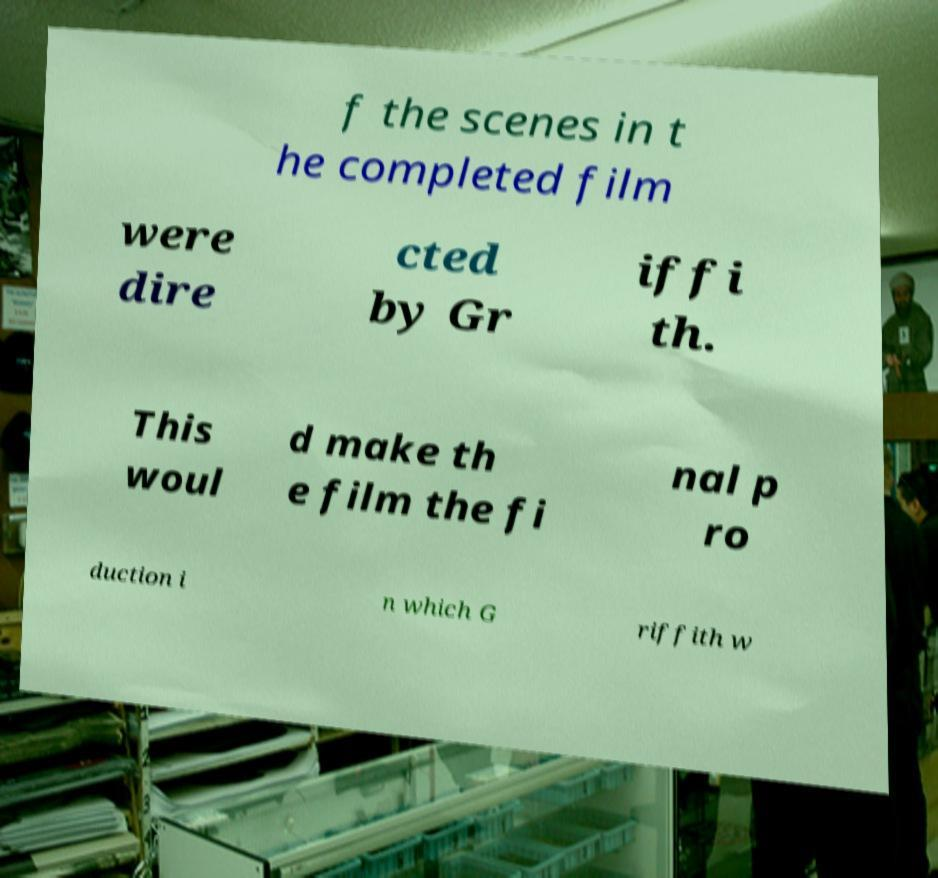I need the written content from this picture converted into text. Can you do that? f the scenes in t he completed film were dire cted by Gr iffi th. This woul d make th e film the fi nal p ro duction i n which G riffith w 